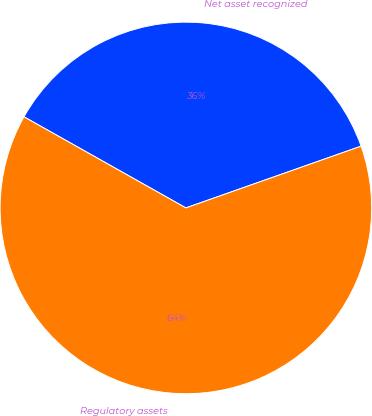Convert chart. <chart><loc_0><loc_0><loc_500><loc_500><pie_chart><fcel>Net asset recognized<fcel>Regulatory assets<nl><fcel>36.45%<fcel>63.55%<nl></chart> 